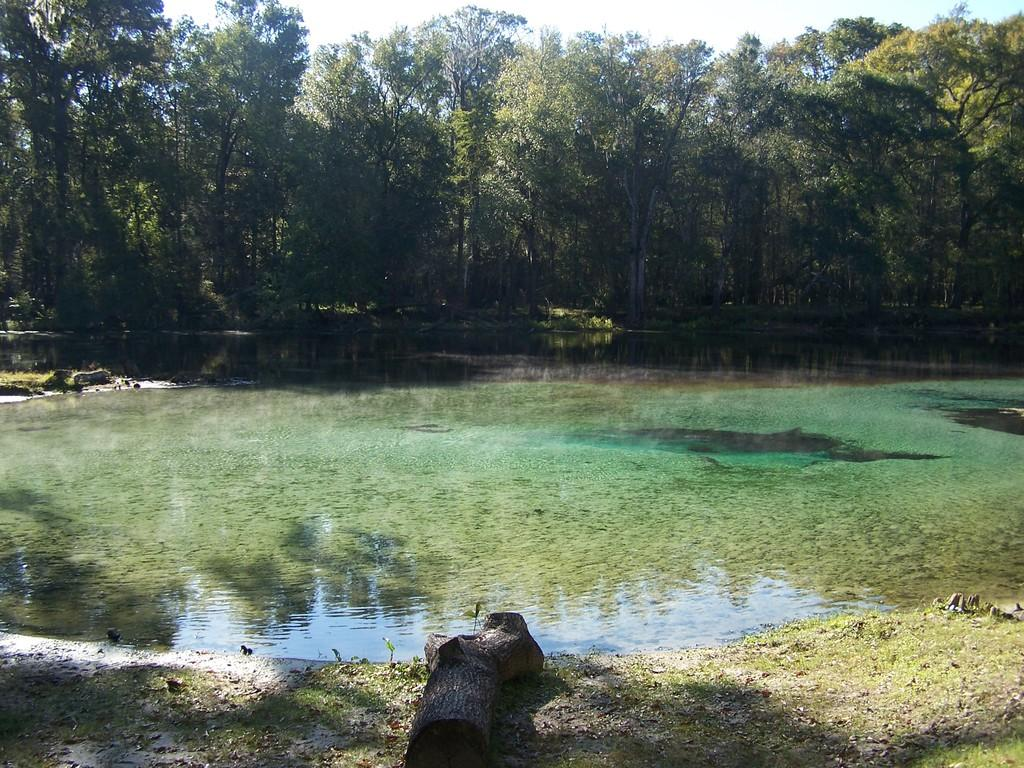What is the primary element visible in the image? There is water in the image. What type of object can be seen at the bottom of the image? There is a wooden object at the bottom of the image. What type of vegetation is present in the image? There is grass in the image. What can be seen in the background of the image? There are trees and the sky visible in the background of the image. What type of stitch is used to hold the water together in the image? There is no stitching involved in the image; it is a natural scene featuring water. Does the existence of the wooden object in the image prove the existence of a parallel universe? The presence of the wooden object in the image does not prove the existence of a parallel universe; it is simply an object in the scene. 